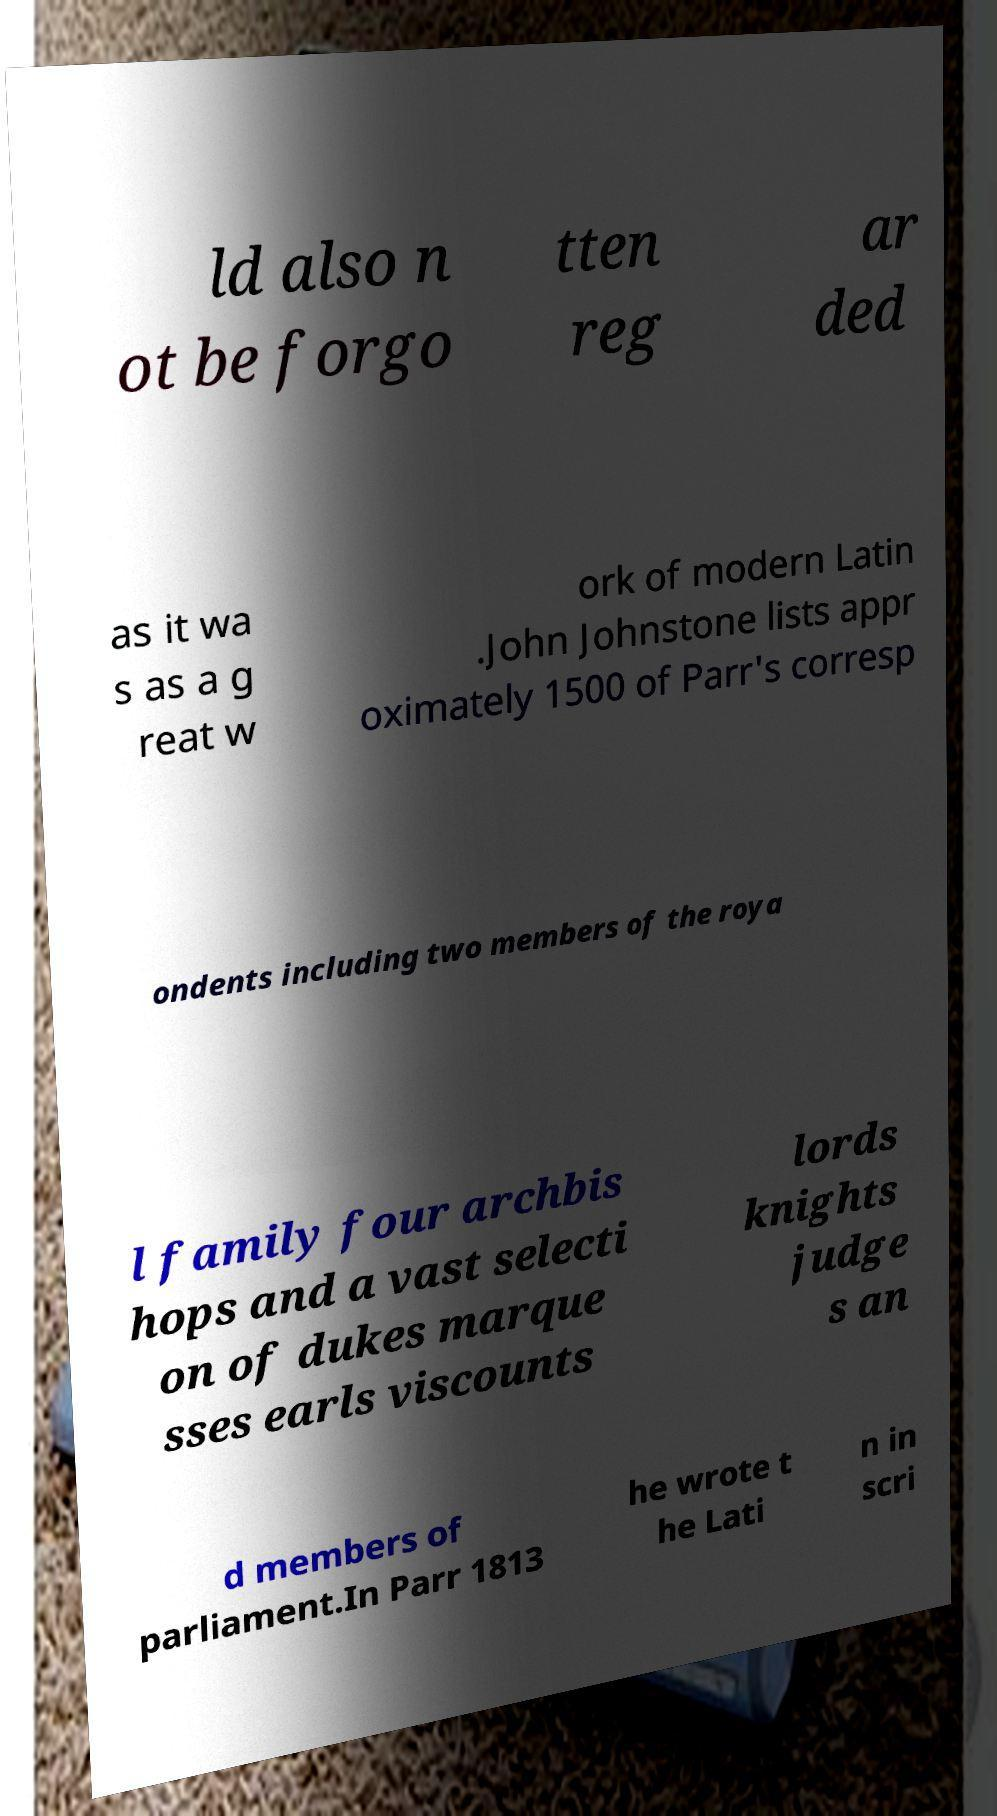Can you read and provide the text displayed in the image?This photo seems to have some interesting text. Can you extract and type it out for me? ld also n ot be forgo tten reg ar ded as it wa s as a g reat w ork of modern Latin .John Johnstone lists appr oximately 1500 of Parr's corresp ondents including two members of the roya l family four archbis hops and a vast selecti on of dukes marque sses earls viscounts lords knights judge s an d members of parliament.In Parr 1813 he wrote t he Lati n in scri 